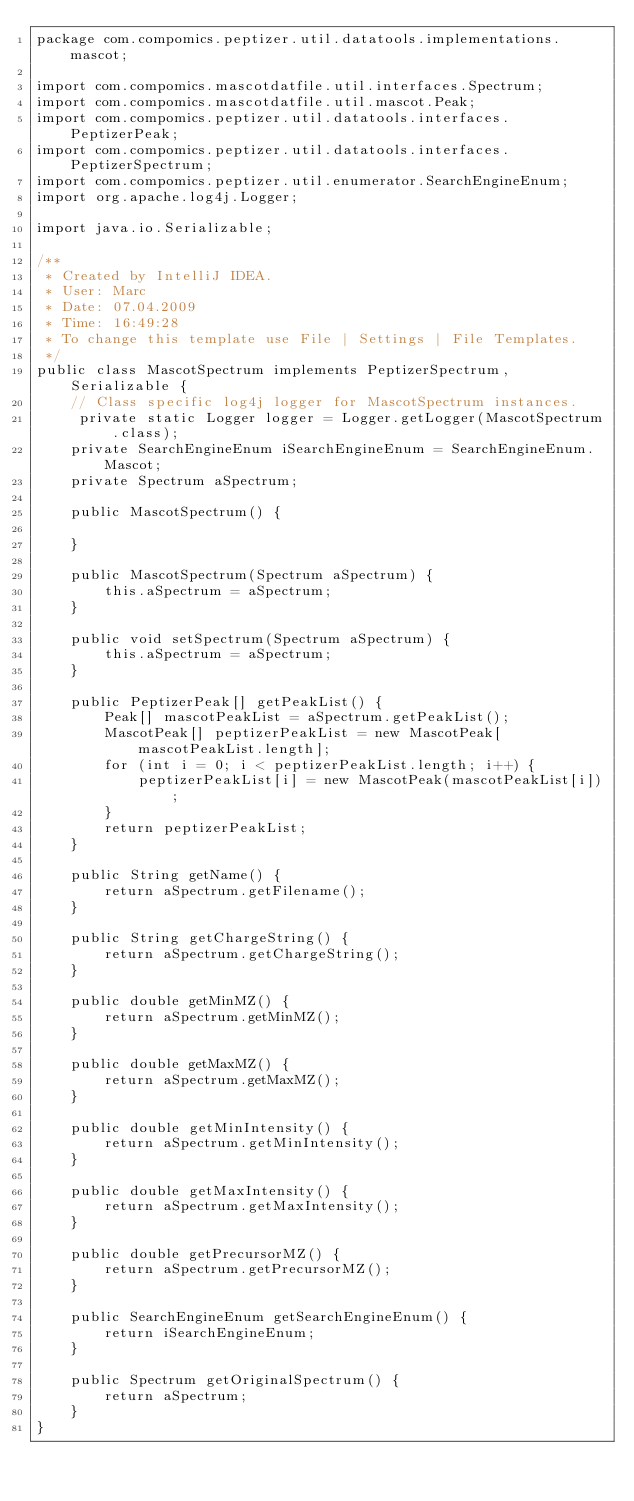Convert code to text. <code><loc_0><loc_0><loc_500><loc_500><_Java_>package com.compomics.peptizer.util.datatools.implementations.mascot;

import com.compomics.mascotdatfile.util.interfaces.Spectrum;
import com.compomics.mascotdatfile.util.mascot.Peak;
import com.compomics.peptizer.util.datatools.interfaces.PeptizerPeak;
import com.compomics.peptizer.util.datatools.interfaces.PeptizerSpectrum;
import com.compomics.peptizer.util.enumerator.SearchEngineEnum;
import org.apache.log4j.Logger;

import java.io.Serializable;

/**
 * Created by IntelliJ IDEA.
 * User: Marc
 * Date: 07.04.2009
 * Time: 16:49:28
 * To change this template use File | Settings | File Templates.
 */
public class MascotSpectrum implements PeptizerSpectrum, Serializable {
	// Class specific log4j logger for MascotSpectrum instances.
	 private static Logger logger = Logger.getLogger(MascotSpectrum.class);
    private SearchEngineEnum iSearchEngineEnum = SearchEngineEnum.Mascot;
    private Spectrum aSpectrum;

    public MascotSpectrum() {

    }

    public MascotSpectrum(Spectrum aSpectrum) {
        this.aSpectrum = aSpectrum;
    }

    public void setSpectrum(Spectrum aSpectrum) {
        this.aSpectrum = aSpectrum;
    }

    public PeptizerPeak[] getPeakList() {
        Peak[] mascotPeakList = aSpectrum.getPeakList();
        MascotPeak[] peptizerPeakList = new MascotPeak[mascotPeakList.length];
        for (int i = 0; i < peptizerPeakList.length; i++) {
            peptizerPeakList[i] = new MascotPeak(mascotPeakList[i]);
        }
        return peptizerPeakList;
    }

    public String getName() {
        return aSpectrum.getFilename();
    }

    public String getChargeString() {
        return aSpectrum.getChargeString();
    }

    public double getMinMZ() {
        return aSpectrum.getMinMZ();
    }

    public double getMaxMZ() {
        return aSpectrum.getMaxMZ();
    }

    public double getMinIntensity() {
        return aSpectrum.getMinIntensity();
    }

    public double getMaxIntensity() {
        return aSpectrum.getMaxIntensity();
    }

    public double getPrecursorMZ() {
        return aSpectrum.getPrecursorMZ();
    }

    public SearchEngineEnum getSearchEngineEnum() {
        return iSearchEngineEnum;
    }

    public Spectrum getOriginalSpectrum() {
        return aSpectrum;
    }
}
</code> 